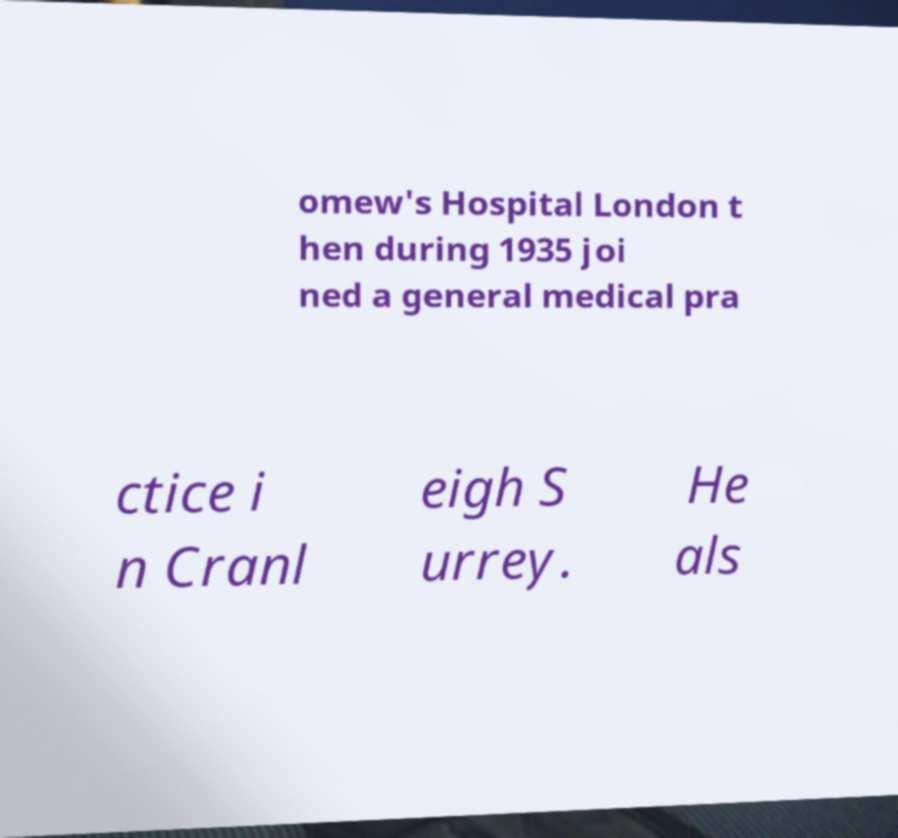Could you assist in decoding the text presented in this image and type it out clearly? omew's Hospital London t hen during 1935 joi ned a general medical pra ctice i n Cranl eigh S urrey. He als 